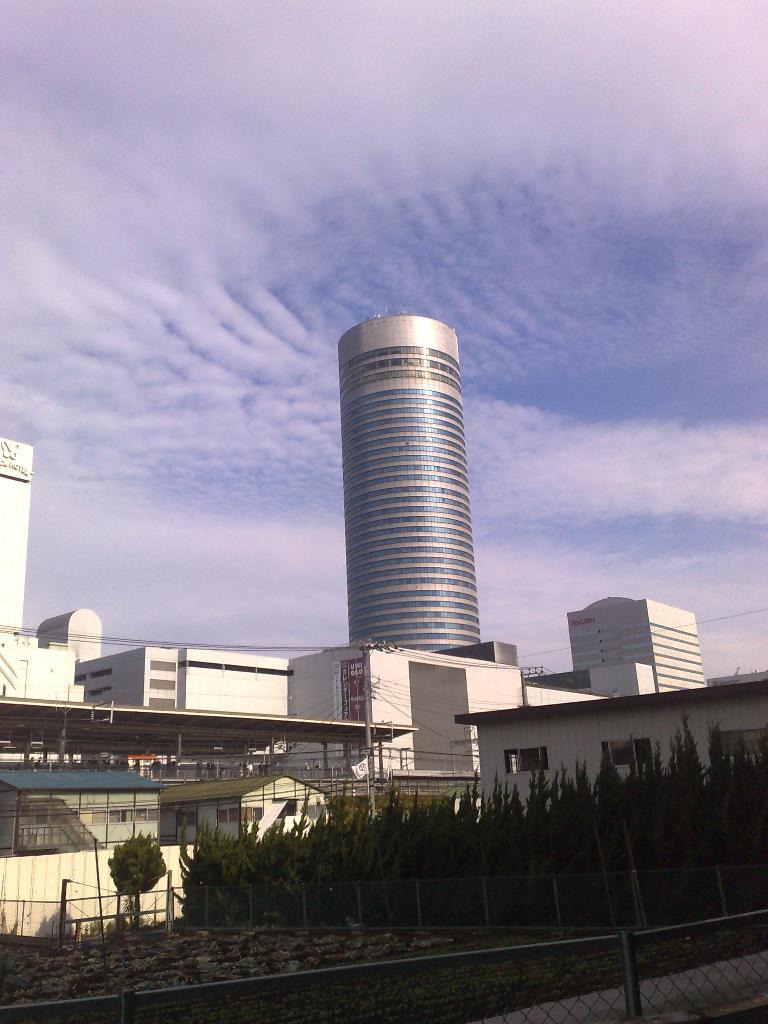Describe this image in one or two sentences. In this image I can see at the bottom there are trees, in the middle there are buildings, at the top it is the cloudy sky. 